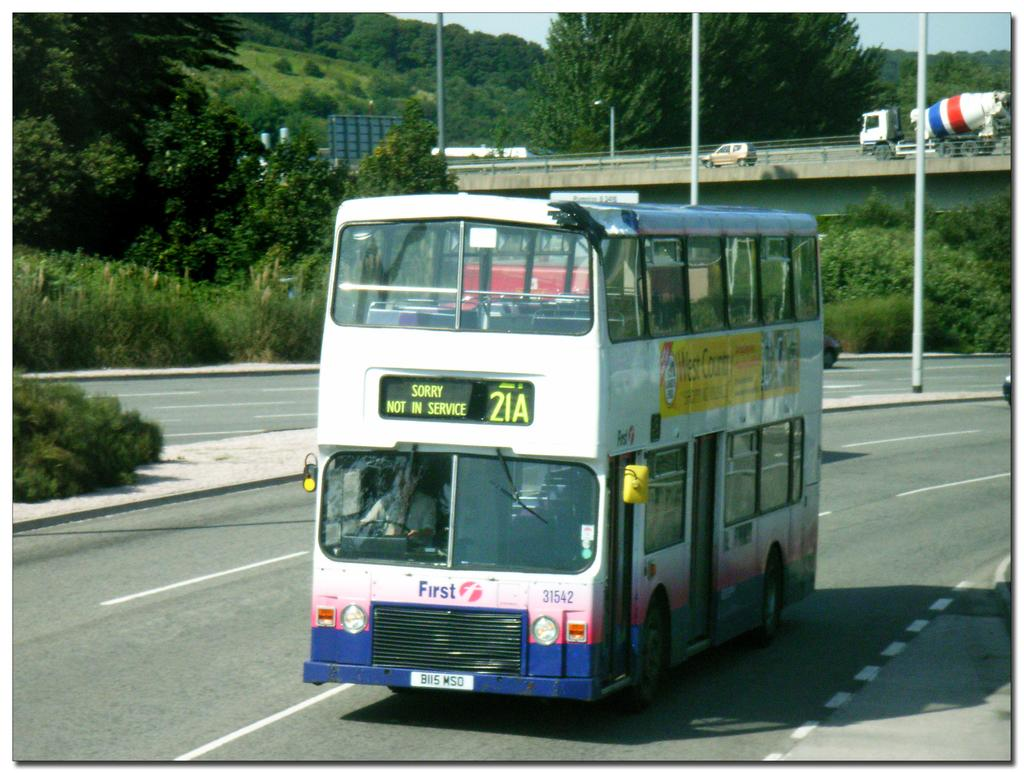<image>
Write a terse but informative summary of the picture. A double Decker bus with the message Sorry Not In Service displayed on its front. 